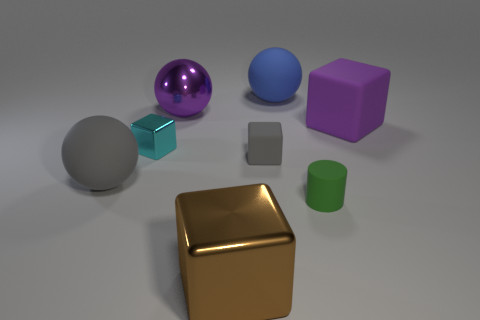There is a gray thing that is the same size as the shiny sphere; what shape is it?
Your response must be concise. Sphere. How many objects are either tiny rubber cubes or large blue rubber balls?
Your answer should be very brief. 2. Are there any large red cylinders?
Provide a short and direct response. No. Is the number of tiny cyan cubes less than the number of blue matte cubes?
Offer a terse response. No. Are there any brown blocks that have the same size as the purple metallic thing?
Your answer should be very brief. Yes. There is a blue rubber object; is it the same shape as the big purple object that is on the right side of the tiny green rubber thing?
Provide a short and direct response. No. What number of cylinders are large purple rubber objects or gray things?
Give a very brief answer. 0. The small metal cube has what color?
Offer a very short reply. Cyan. Is the number of shiny spheres greater than the number of yellow rubber balls?
Ensure brevity in your answer.  Yes. What number of things are either tiny matte objects that are on the left side of the big blue rubber object or blue objects?
Your answer should be compact. 2. 